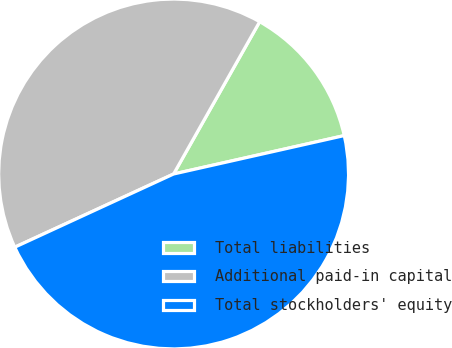<chart> <loc_0><loc_0><loc_500><loc_500><pie_chart><fcel>Total liabilities<fcel>Additional paid-in capital<fcel>Total stockholders' equity<nl><fcel>13.29%<fcel>40.06%<fcel>46.65%<nl></chart> 